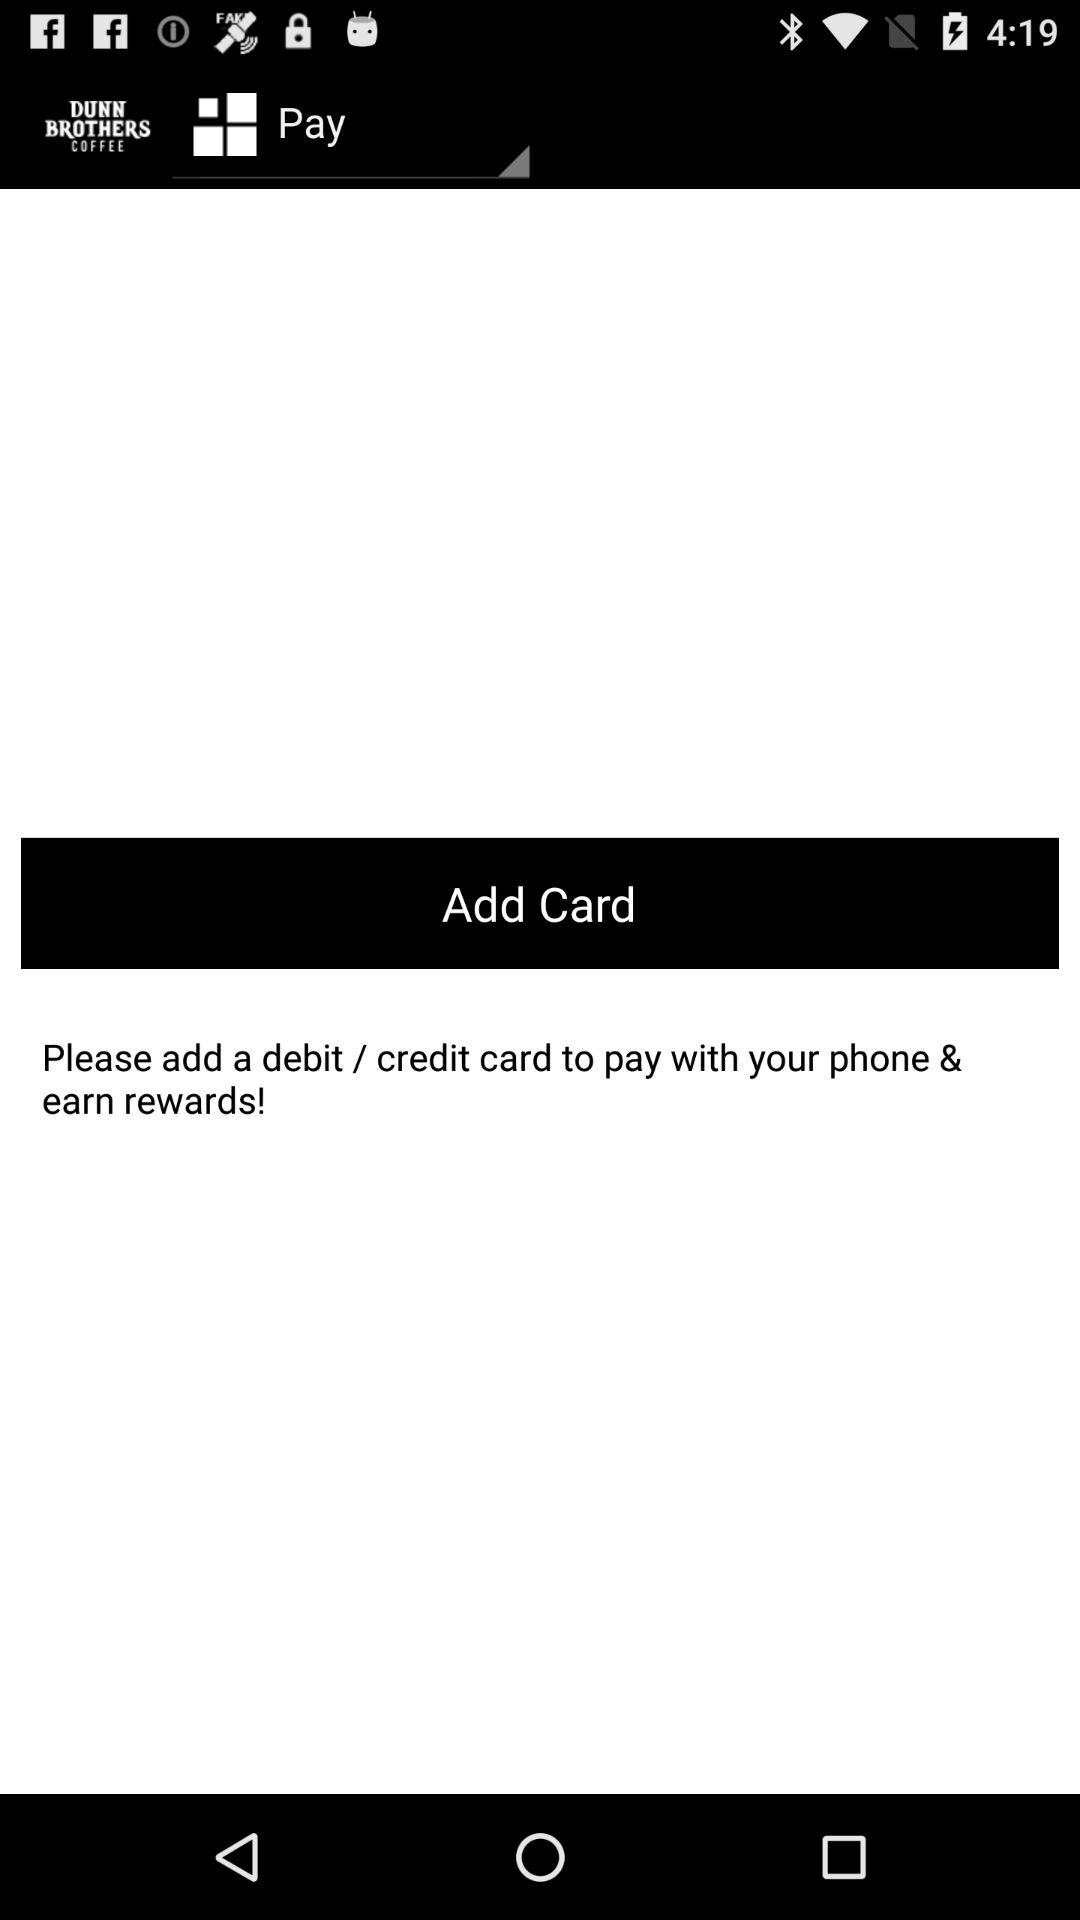What is the name of the application? The name of the application is "DUNN BROTHERS COFFEE". 